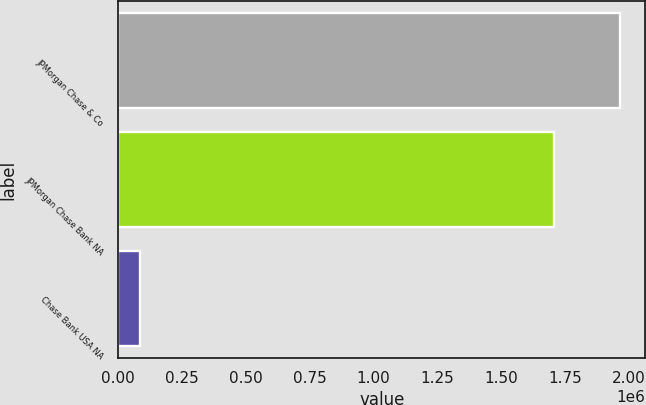<chart> <loc_0><loc_0><loc_500><loc_500><bar_chart><fcel>JPMorgan Chase & Co<fcel>JPMorgan Chase Bank NA<fcel>Chase Bank USA NA<nl><fcel>1.9669e+06<fcel>1.70575e+06<fcel>87286<nl></chart> 